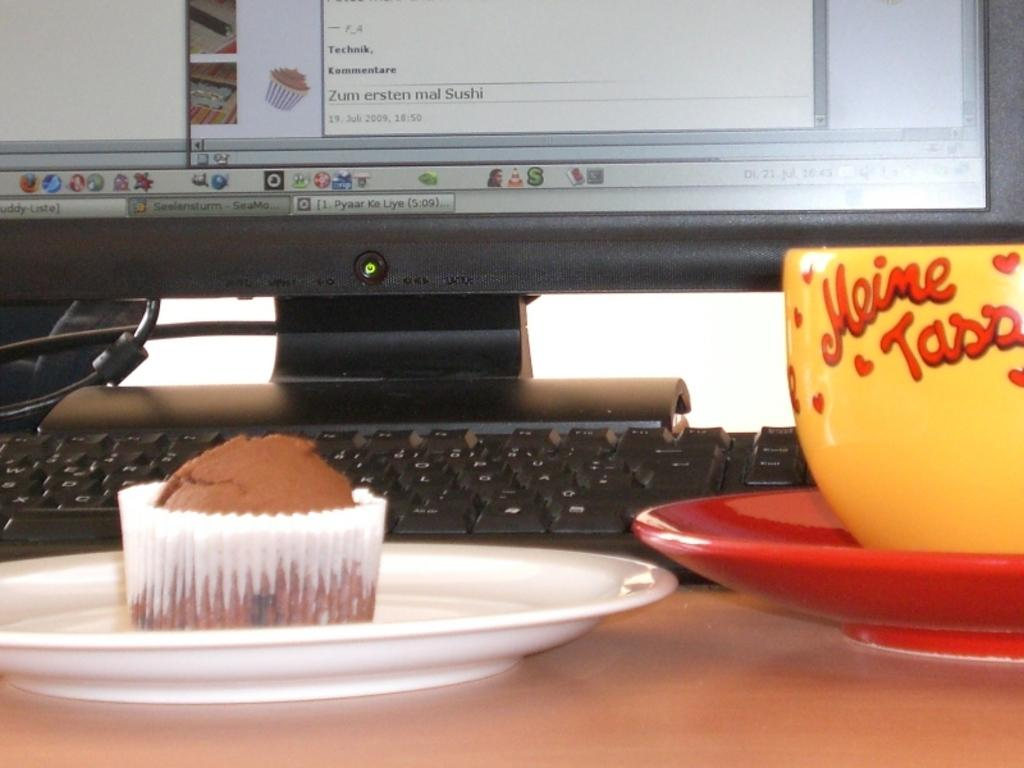What type of electronic device is visible in the image? There is a monitor in the image. What is used for typing or inputting commands in the image? There is a keyboard in the image. What is the purpose of the cup and saucer in the image? The cup and saucer are likely used for holding a beverage. What is the dessert item placed on the plate in the image? There is a cupcake on the plate in the image. Where are all these objects located in the image? All of these objects are placed on a table. What type of tray is used to serve the cupcake in the image? There is no tray present in the image; the cupcake is placed directly on the plate. What type of judge is depicted in the image? There is no judge depicted in the image; the focus is on the objects placed on the table. Can you see any bees buzzing around the cupcake in the image? There are no bees present in the image; it only features the cupcake, plate, saucer, cup, keyboard, and monitor. 